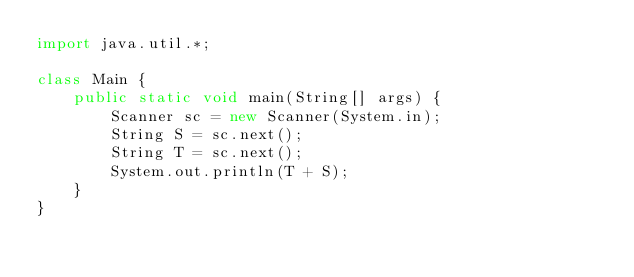<code> <loc_0><loc_0><loc_500><loc_500><_Java_>import java.util.*;

class Main {
    public static void main(String[] args) {
        Scanner sc = new Scanner(System.in);
        String S = sc.next();
        String T = sc.next();
        System.out.println(T + S);
    }
}
</code> 